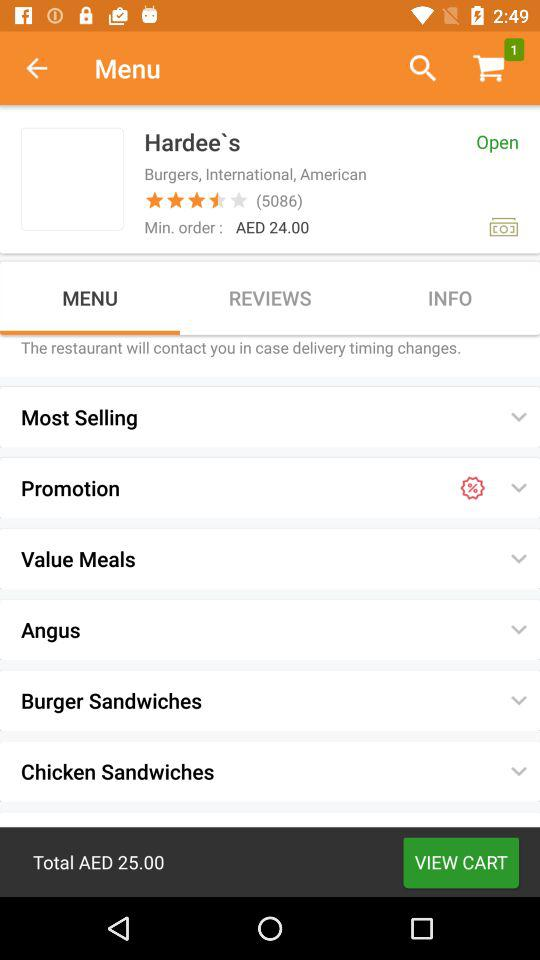How much is the total price?
Answer the question using a single word or phrase. AED 25.00 